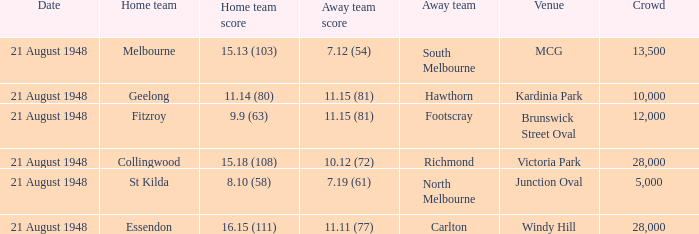If the Away team is north melbourne, what's the Home team score? 8.10 (58). 